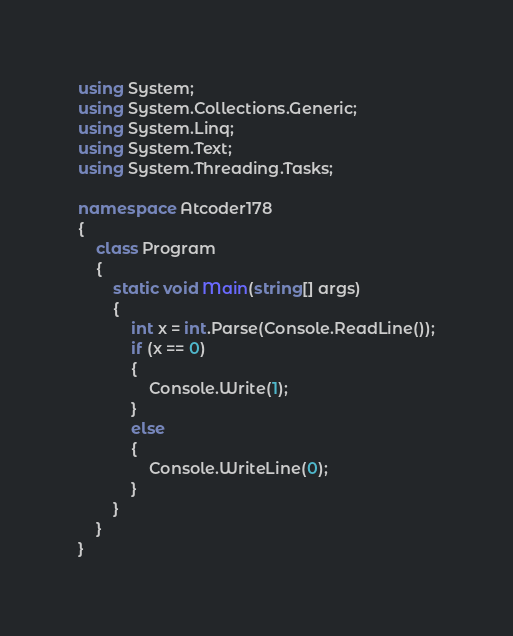<code> <loc_0><loc_0><loc_500><loc_500><_C#_>using System;
using System.Collections.Generic;
using System.Linq;
using System.Text;
using System.Threading.Tasks;

namespace Atcoder178
{
    class Program
    {
        static void Main(string[] args)
        {
            int x = int.Parse(Console.ReadLine());
            if (x == 0)
            {
                Console.Write(1);
            }
            else
            {
                Console.WriteLine(0);
            }
        }
    }
}</code> 